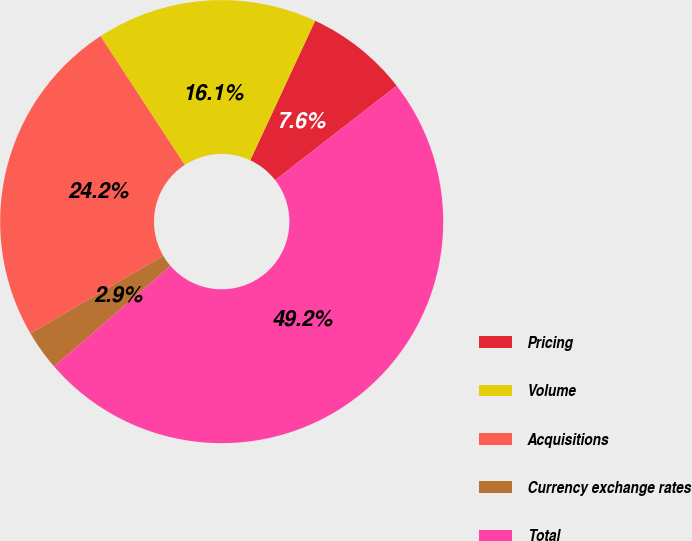Convert chart to OTSL. <chart><loc_0><loc_0><loc_500><loc_500><pie_chart><fcel>Pricing<fcel>Volume<fcel>Acquisitions<fcel>Currency exchange rates<fcel>Total<nl><fcel>7.56%<fcel>16.14%<fcel>24.21%<fcel>2.93%<fcel>49.16%<nl></chart> 